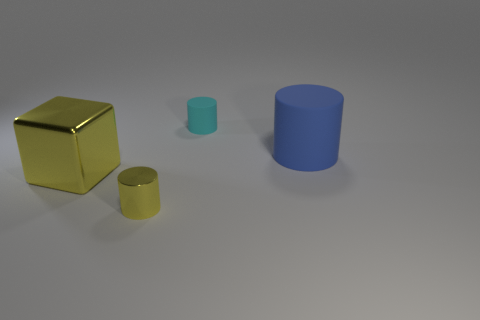Can you describe the lighting in the scene? The lighting appears to be soft and diffused, coming from the upper left side. It casts gentle shadows to the right of the objects, giving the scene a calm and uniform look. 